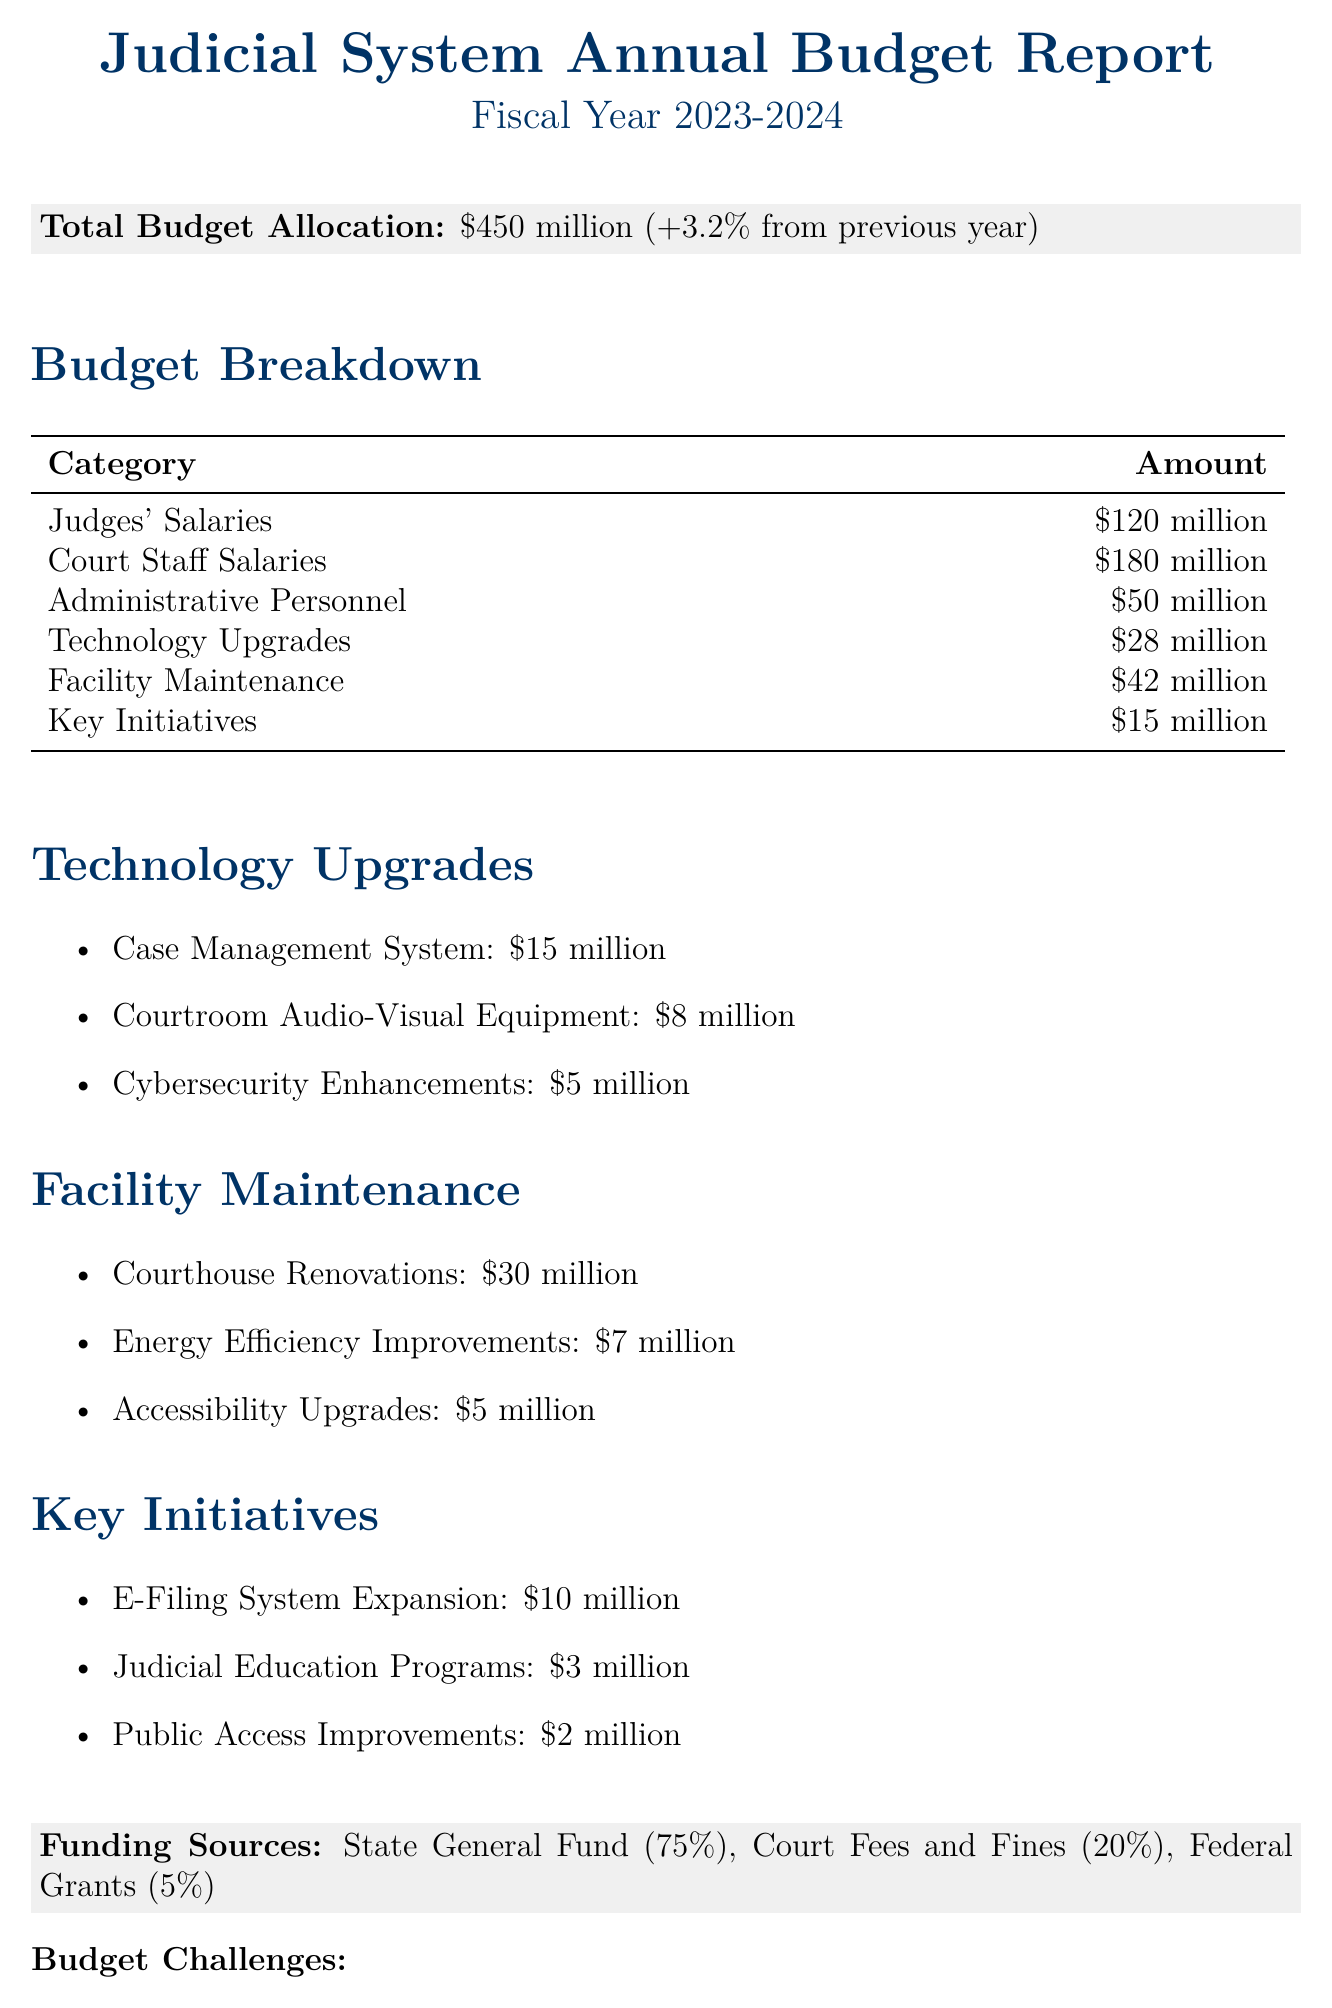What is the total budget allocation? The total budget allocation is stated at the top of the document as $450 million.
Answer: $450 million How much is allocated for judges' salaries? The document provides a specific figure for judges' salaries, listed as $120 million.
Answer: $120 million What percentage of the budget comes from the state general fund? The percentage sourced from the state general fund is indicated as 75%.
Answer: 75% What is the amount earmarked for courthouse renovations? The amount designated for courthouse renovations is clearly outlined as $30 million.
Answer: $30 million What are the main budget challenges mentioned? The challenges include increasing caseloads, aging infrastructure, and technological advancements.
Answer: Increasing caseloads How much is designated for technology upgrades? The total amount for technology upgrades is calculated and indicated in the budget breakdown as $28 million.
Answer: $28 million What is the total amount allocated for key initiatives? The total amount for the outlined key initiatives is written as $15 million.
Answer: $15 million What is the amount set aside for cybersecurity enhancements? The document lists the amount allocated for cybersecurity enhancements as $5 million.
Answer: $5 million How much is allocated for judicial education programs? The budget allocates $3 million specifically for judicial education programs.
Answer: $3 million 